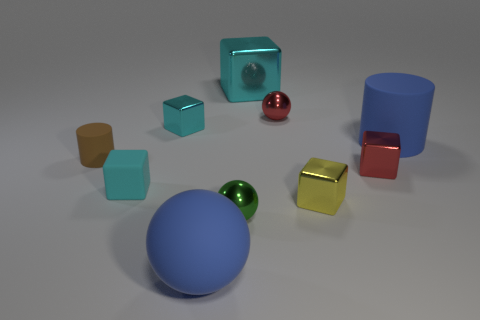Is the size of the cyan block in front of the small cyan metallic block the same as the cyan block behind the red metallic sphere?
Ensure brevity in your answer.  No. Is there a large cyan cube that is left of the small red metallic object that is behind the blue matte object that is on the right side of the large cyan shiny cube?
Your answer should be compact. Yes. Is the number of small blocks that are left of the small cyan rubber object less than the number of cyan shiny objects that are behind the yellow shiny thing?
Your response must be concise. Yes. The red object that is the same material as the small red block is what shape?
Provide a short and direct response. Sphere. There is a yellow block in front of the cylinder on the left side of the big rubber object that is right of the red metallic sphere; how big is it?
Provide a succinct answer. Small. Is the number of purple balls greater than the number of small metal spheres?
Ensure brevity in your answer.  No. There is a rubber cylinder that is to the left of the red shiny ball; is it the same color as the metal ball that is behind the large matte cylinder?
Make the answer very short. No. Is the material of the cyan thing that is behind the red ball the same as the cyan thing that is in front of the tiny brown thing?
Keep it short and to the point. No. How many blue cylinders are the same size as the brown rubber object?
Your answer should be very brief. 0. Are there fewer green shiny blocks than big blocks?
Give a very brief answer. Yes. 